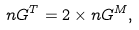<formula> <loc_0><loc_0><loc_500><loc_500>n G ^ { T } = 2 \times n G ^ { M } ,</formula> 